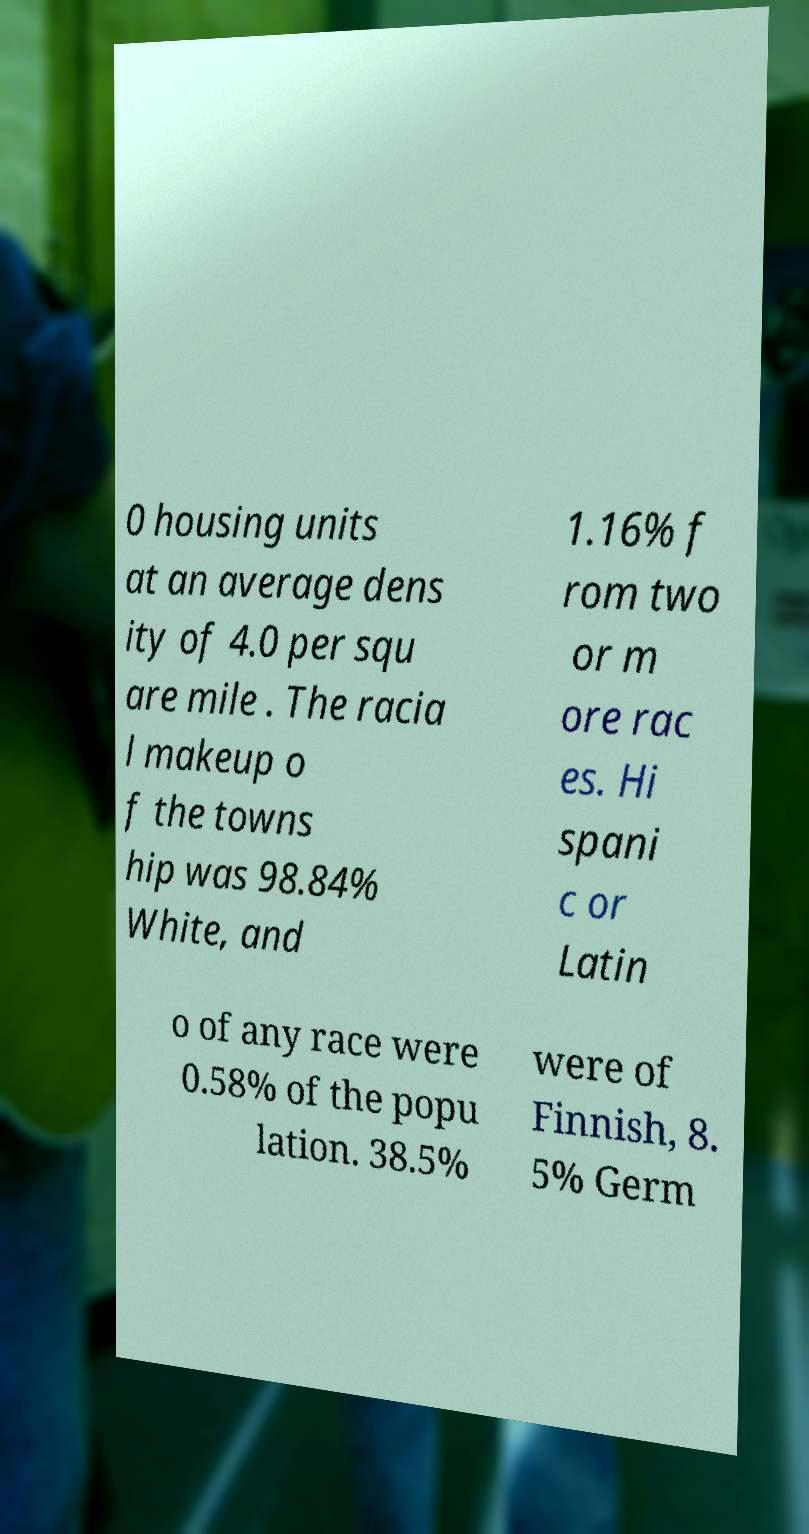Could you assist in decoding the text presented in this image and type it out clearly? 0 housing units at an average dens ity of 4.0 per squ are mile . The racia l makeup o f the towns hip was 98.84% White, and 1.16% f rom two or m ore rac es. Hi spani c or Latin o of any race were 0.58% of the popu lation. 38.5% were of Finnish, 8. 5% Germ 